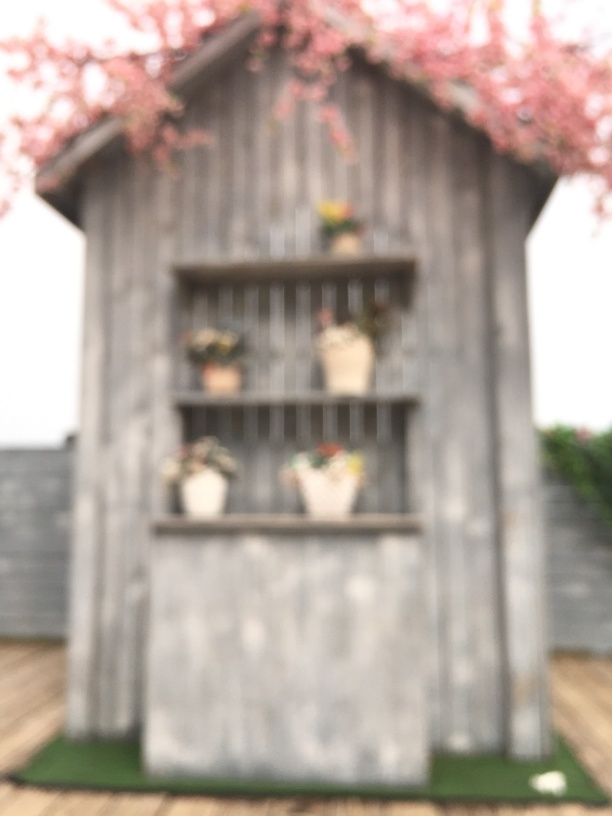Does the image have slight noise? Indeed, the image has noticeable visual noise, characterized by a grainy appearance which might be due to low lighting conditions or high ISO settings used during the capture. This can also be attributed to the image's intentional soft focus and artistic blur that adds to its aesthetic appeal. 